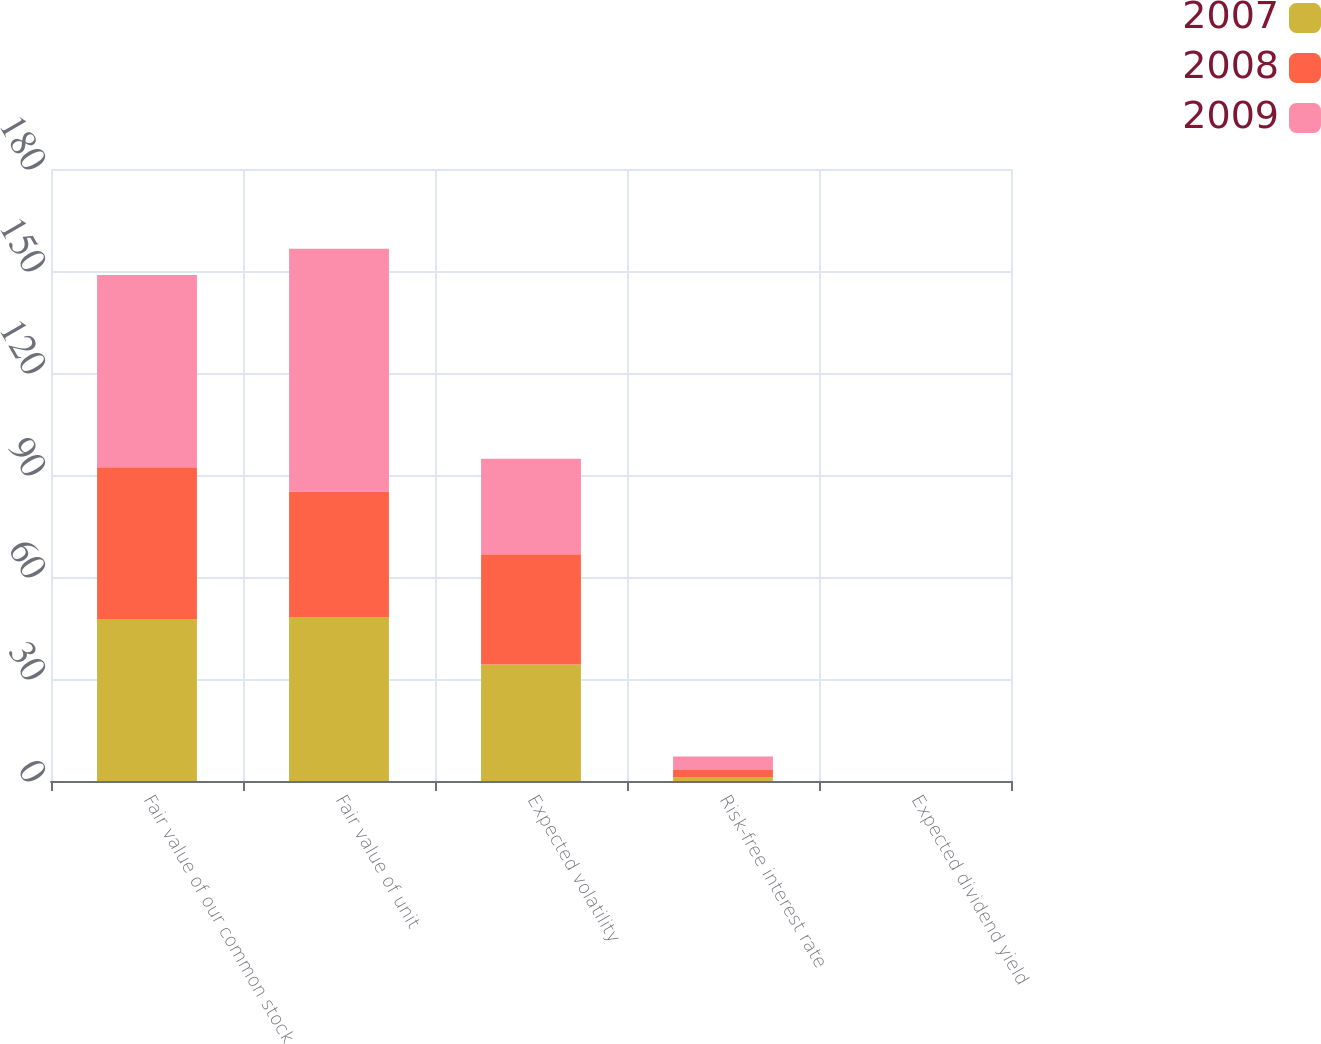Convert chart. <chart><loc_0><loc_0><loc_500><loc_500><stacked_bar_chart><ecel><fcel>Fair value of our common stock<fcel>Fair value of unit<fcel>Expected volatility<fcel>Risk-free interest rate<fcel>Expected dividend yield<nl><fcel>2007<fcel>47.63<fcel>48.22<fcel>34.3<fcel>1.2<fcel>0<nl><fcel>2008<fcel>44.62<fcel>36.91<fcel>32.4<fcel>2<fcel>0<nl><fcel>2009<fcel>56.56<fcel>71.41<fcel>28.1<fcel>4<fcel>0<nl></chart> 